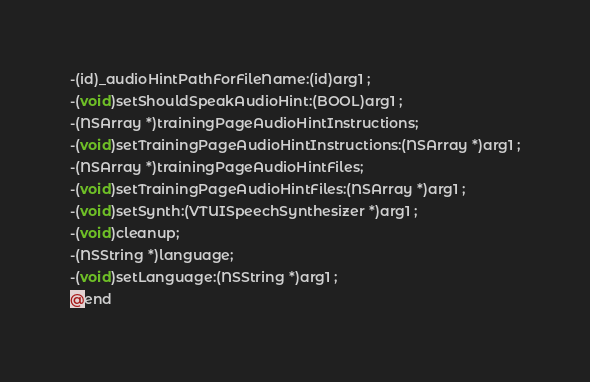<code> <loc_0><loc_0><loc_500><loc_500><_C_>-(id)_audioHintPathForFileName:(id)arg1 ;
-(void)setShouldSpeakAudioHint:(BOOL)arg1 ;
-(NSArray *)trainingPageAudioHintInstructions;
-(void)setTrainingPageAudioHintInstructions:(NSArray *)arg1 ;
-(NSArray *)trainingPageAudioHintFiles;
-(void)setTrainingPageAudioHintFiles:(NSArray *)arg1 ;
-(void)setSynth:(VTUISpeechSynthesizer *)arg1 ;
-(void)cleanup;
-(NSString *)language;
-(void)setLanguage:(NSString *)arg1 ;
@end

</code> 